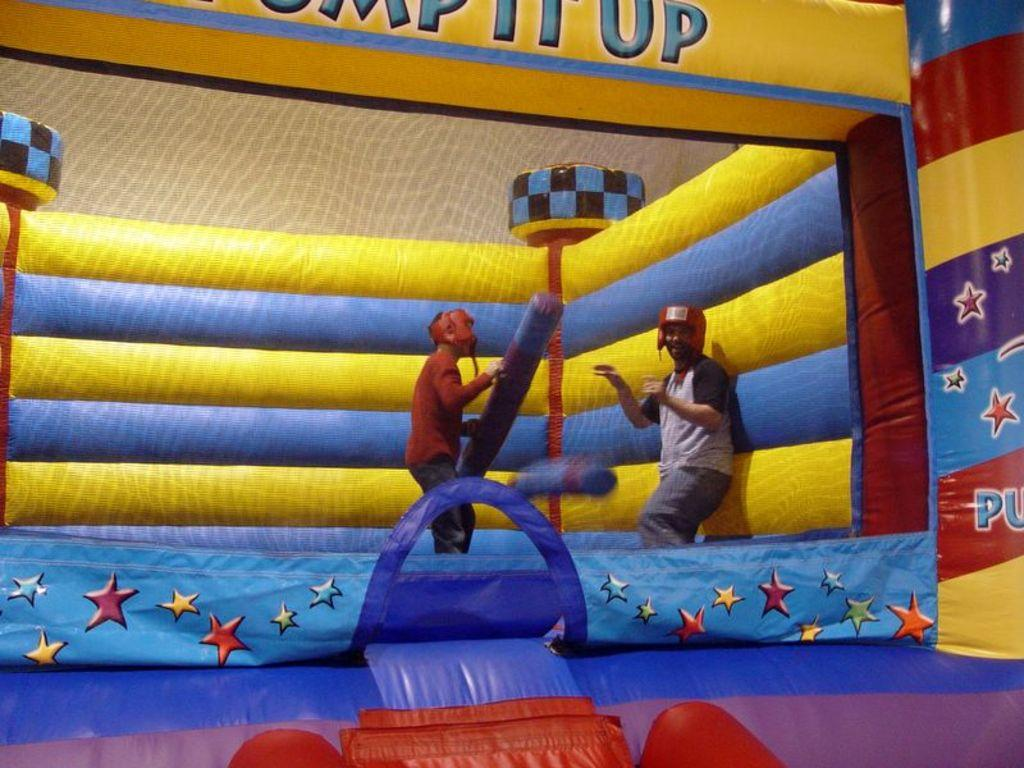How many people are in the image? There are two persons in the image. What are the two persons doing in the image? The two persons are standing on an inflatable object. Can you describe the object one of the persons is holding? One of the persons is holding an object in their hands, but the specifics of the object are not clear from the image. What type of property can be seen in the background of the image? There is no property visible in the background of the image. Are the two persons in the image sharing a kiss? There is no indication of a kiss between the two persons in the image. 